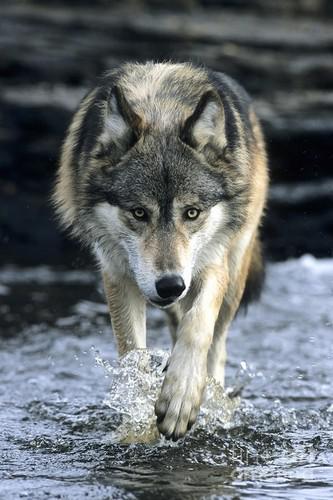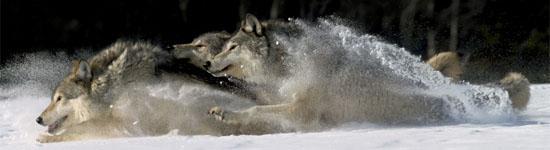The first image is the image on the left, the second image is the image on the right. Given the left and right images, does the statement "All images show wolves on snow, and the right image contains more wolves than the left image." hold true? Answer yes or no. No. The first image is the image on the left, the second image is the image on the right. Given the left and right images, does the statement "There are seven wolves in total." hold true? Answer yes or no. No. 